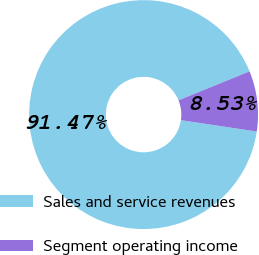Convert chart to OTSL. <chart><loc_0><loc_0><loc_500><loc_500><pie_chart><fcel>Sales and service revenues<fcel>Segment operating income<nl><fcel>91.47%<fcel>8.53%<nl></chart> 